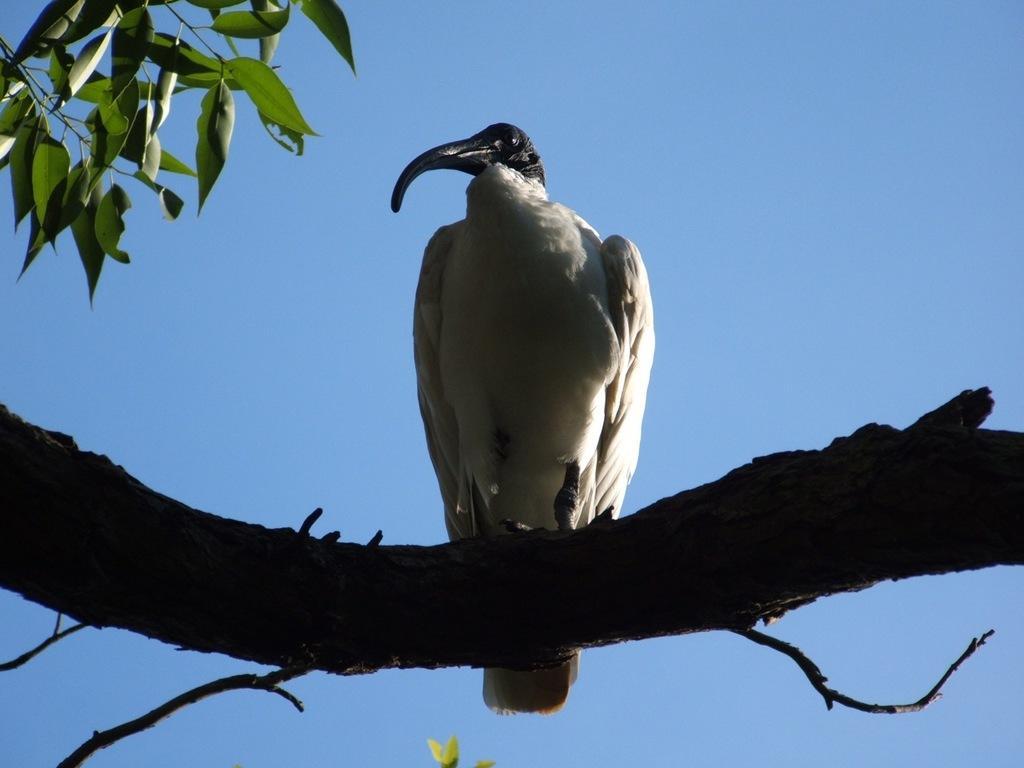In one or two sentences, can you explain what this image depicts? In this image, we can see a bird on a tree branch. Here we can see stems and leaves. Background we can see the sky. 